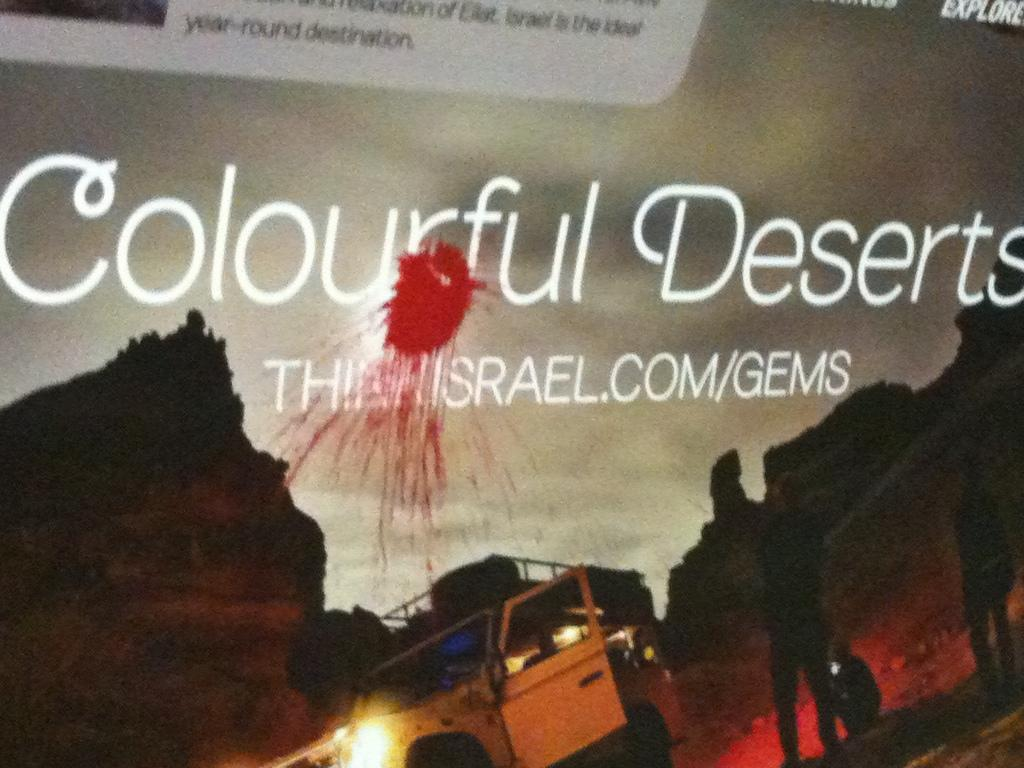<image>
Relay a brief, clear account of the picture shown. A sign shows a jeep and the words, colorful deserts. 